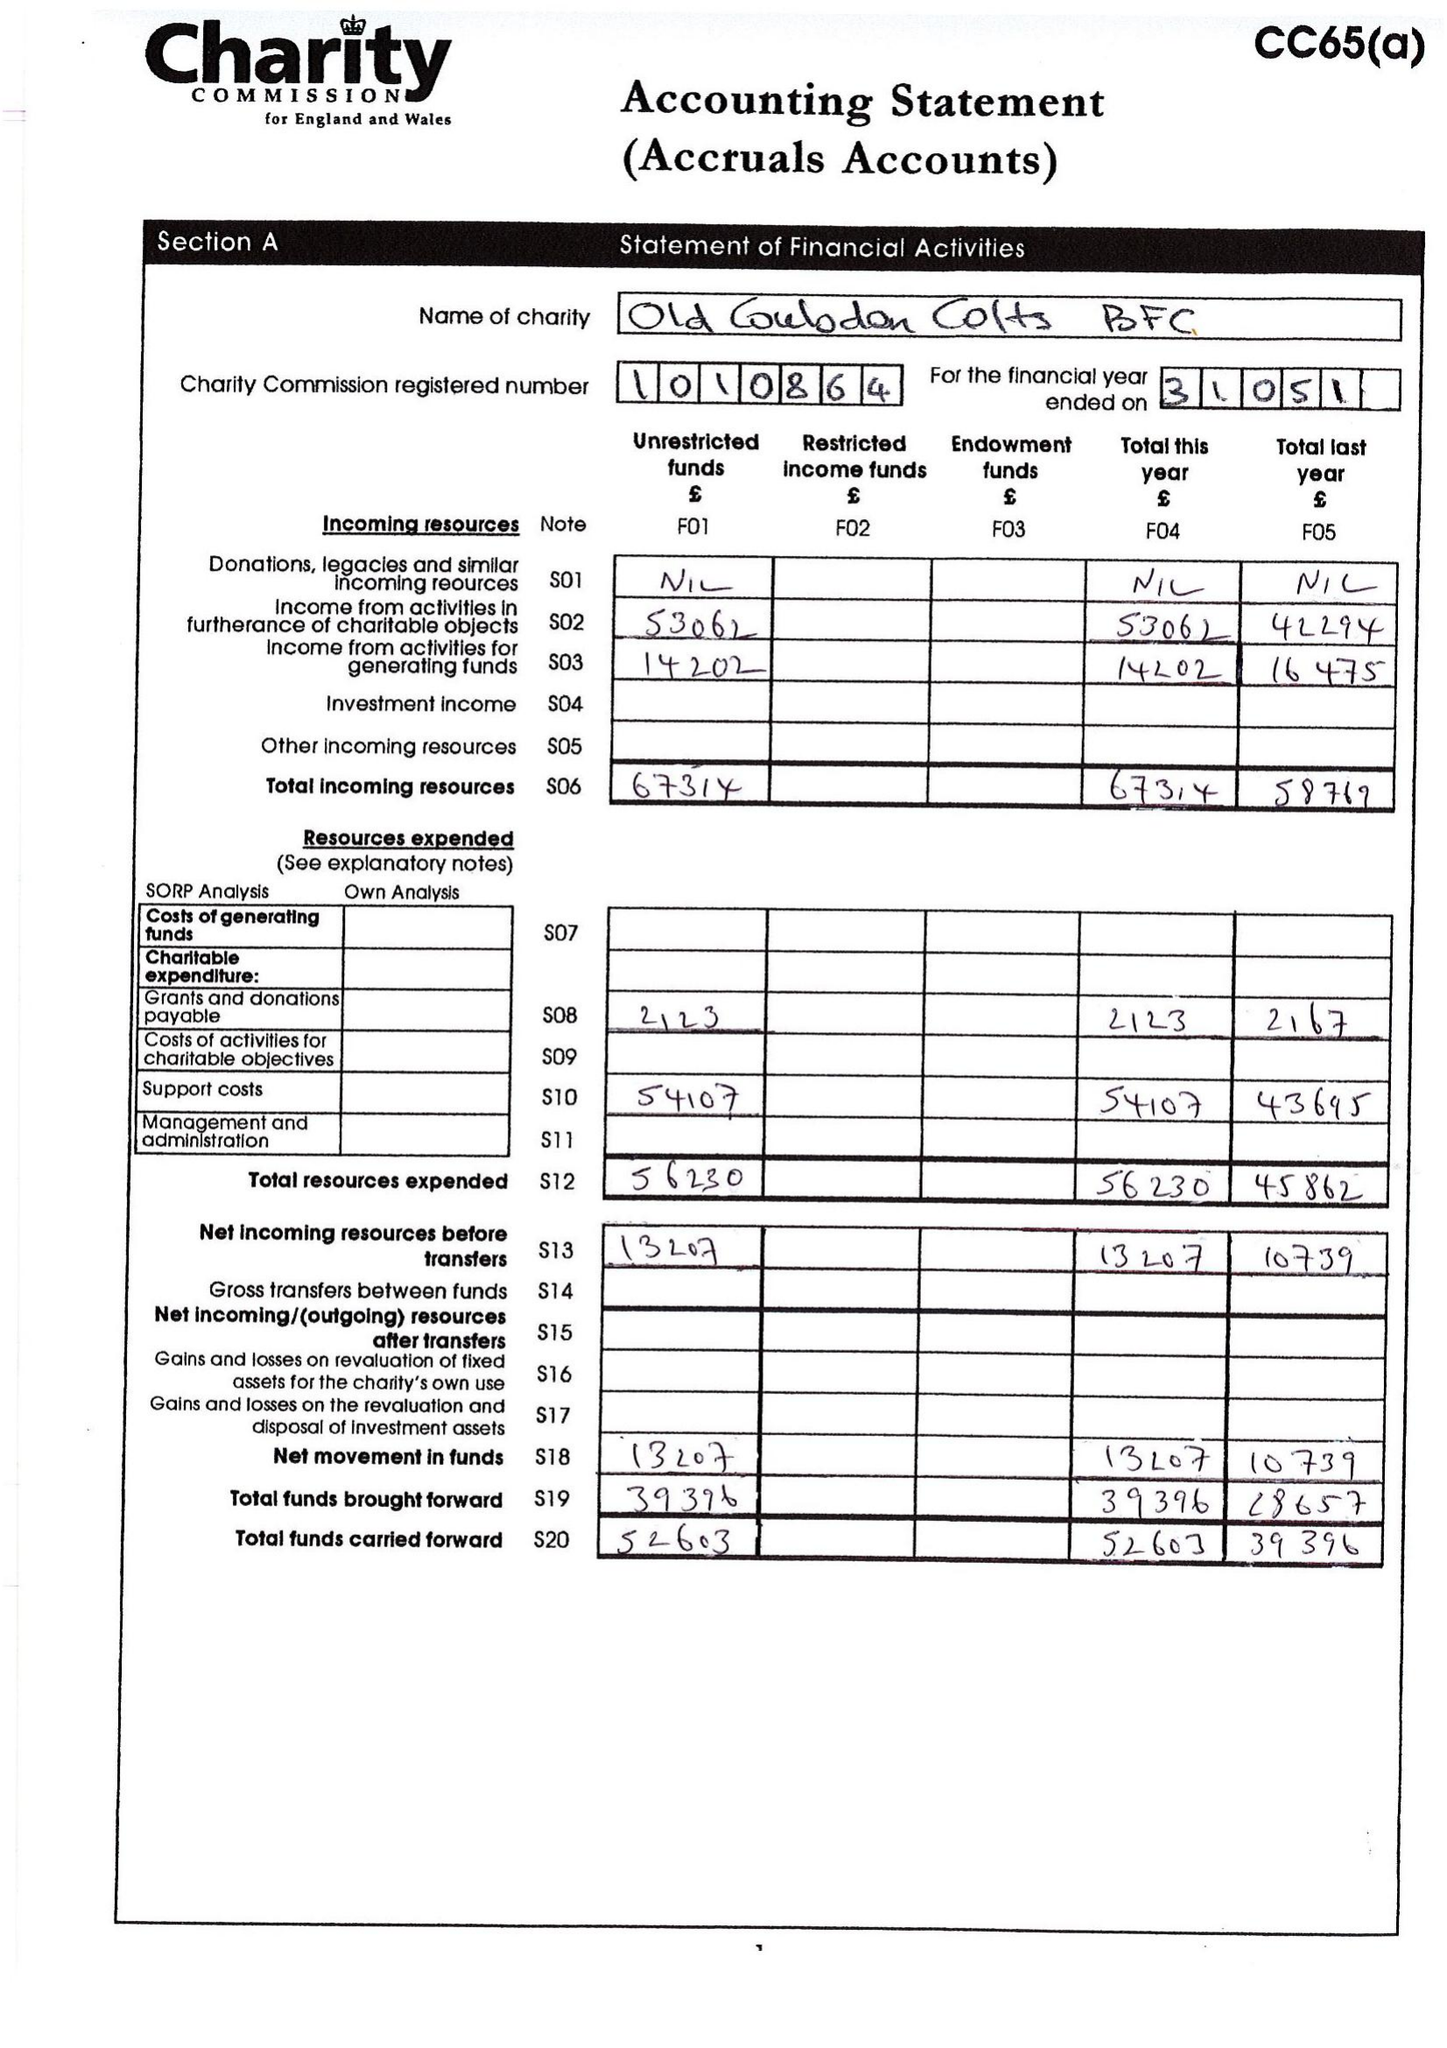What is the value for the address__postcode?
Answer the question using a single word or phrase. CR5 1BF 